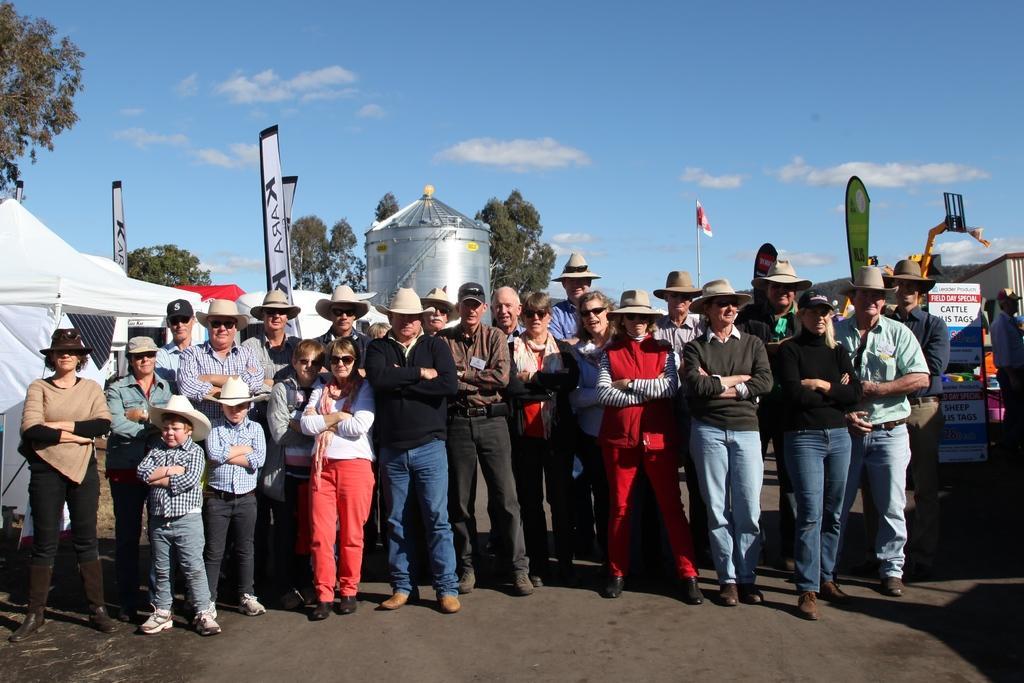Describe this image in one or two sentences. This picture is clicked outside the city. In front of the picture, we see people are standing on the road. Most of them are wearing hats. On the left side, we see tents in white and red color. Behind that, we see a steel thing which looks like a water tanker. On the right side, we see boards with some text written on it. Behind that, we see a crane and buildings. In the background, there are trees and a flag in red and white color. At the top of the picture, we see the sky. 